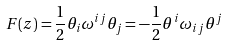<formula> <loc_0><loc_0><loc_500><loc_500>F ( z ) = \frac { 1 } { 2 } \theta _ { i } \omega ^ { i j } \theta _ { j } = - \frac { 1 } { 2 } \theta ^ { i } \omega _ { i j } \theta ^ { j }</formula> 